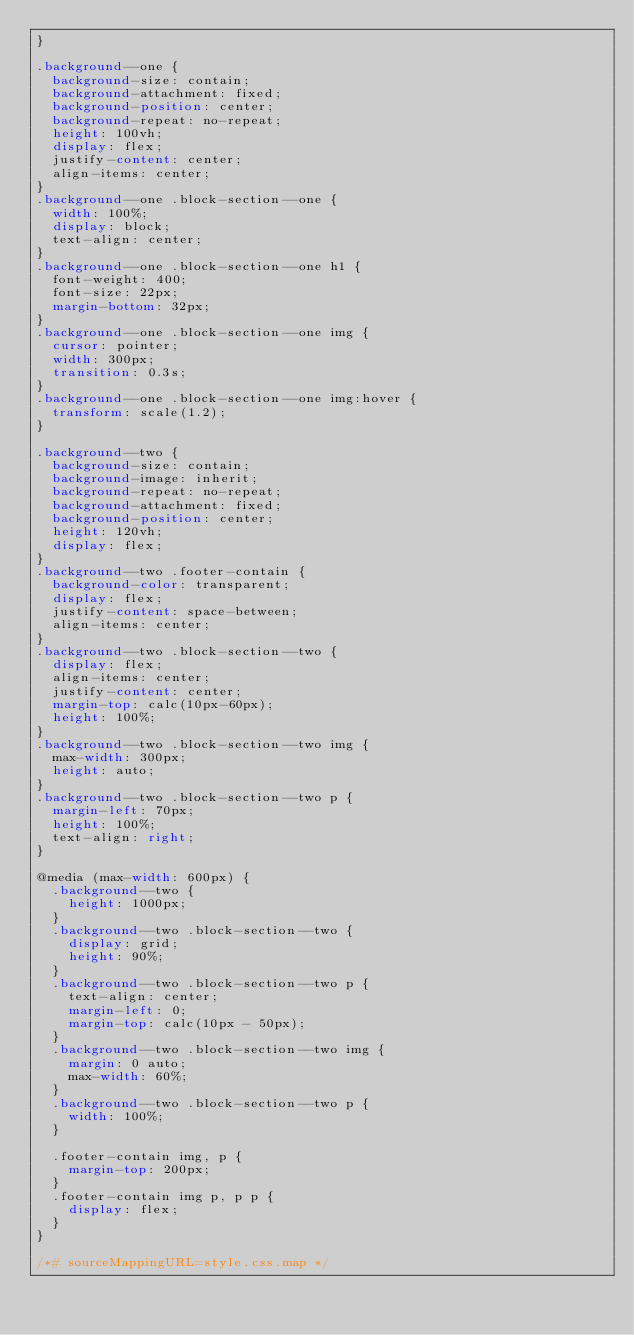<code> <loc_0><loc_0><loc_500><loc_500><_CSS_>}

.background--one {
  background-size: contain;
  background-attachment: fixed;
  background-position: center;
  background-repeat: no-repeat;
  height: 100vh;
  display: flex;
  justify-content: center;
  align-items: center;
}
.background--one .block-section--one {
  width: 100%;
  display: block;
  text-align: center;
}
.background--one .block-section--one h1 {
  font-weight: 400;
  font-size: 22px;
  margin-bottom: 32px;
}
.background--one .block-section--one img {
  cursor: pointer;
  width: 300px;
  transition: 0.3s;
}
.background--one .block-section--one img:hover {
  transform: scale(1.2);
}

.background--two {
  background-size: contain;
  background-image: inherit;
  background-repeat: no-repeat;
  background-attachment: fixed;
  background-position: center;
  height: 120vh;
  display: flex;
}
.background--two .footer-contain {
  background-color: transparent;
  display: flex;
  justify-content: space-between;
  align-items: center;
}
.background--two .block-section--two {
  display: flex;
  align-items: center;
  justify-content: center;
  margin-top: calc(10px-60px);
  height: 100%;
}
.background--two .block-section--two img {
  max-width: 300px;
  height: auto;
}
.background--two .block-section--two p {
  margin-left: 70px;
  height: 100%;
  text-align: right;
}

@media (max-width: 600px) {
  .background--two {
    height: 1000px;
  }
  .background--two .block-section--two {
    display: grid;
    height: 90%;
  }
  .background--two .block-section--two p {
    text-align: center;
    margin-left: 0;
    margin-top: calc(10px - 50px);
  }
  .background--two .block-section--two img {
    margin: 0 auto;
    max-width: 60%;
  }
  .background--two .block-section--two p {
    width: 100%;
  }

  .footer-contain img, p {
    margin-top: 200px;
  }
  .footer-contain img p, p p {
    display: flex;
  }
}

/*# sourceMappingURL=style.css.map */
</code> 